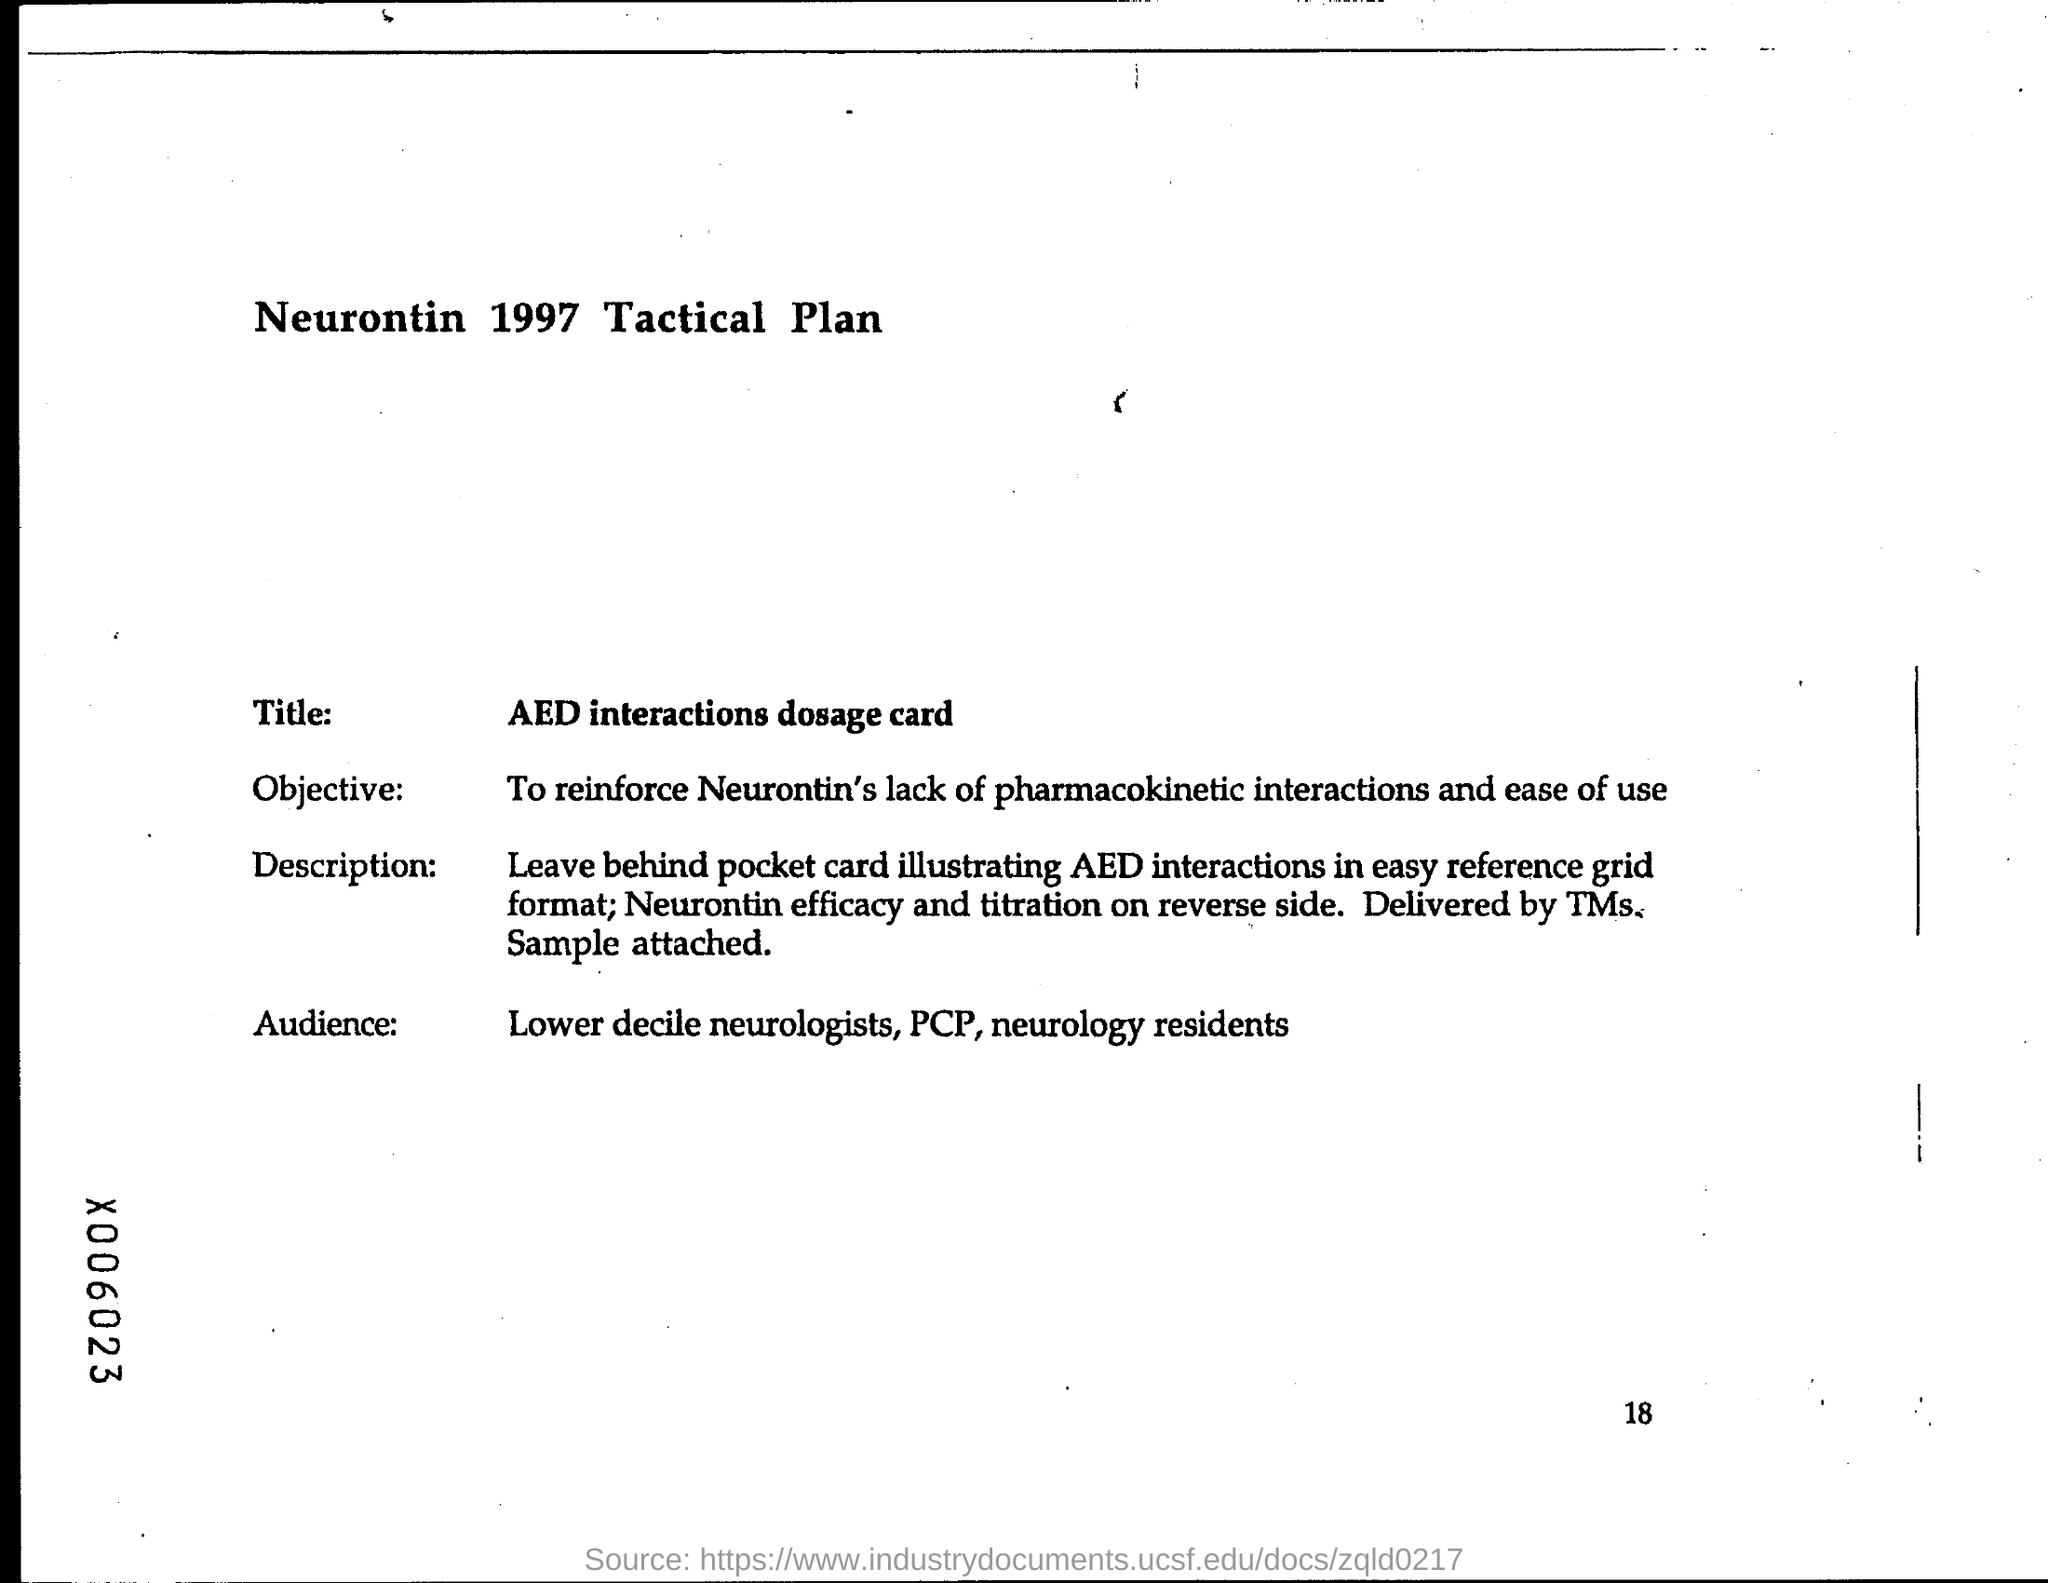What is the title?
Your answer should be compact. Aed interactions dosage card. What is the page number at bottom of the page?
Offer a very short reply. 18. 